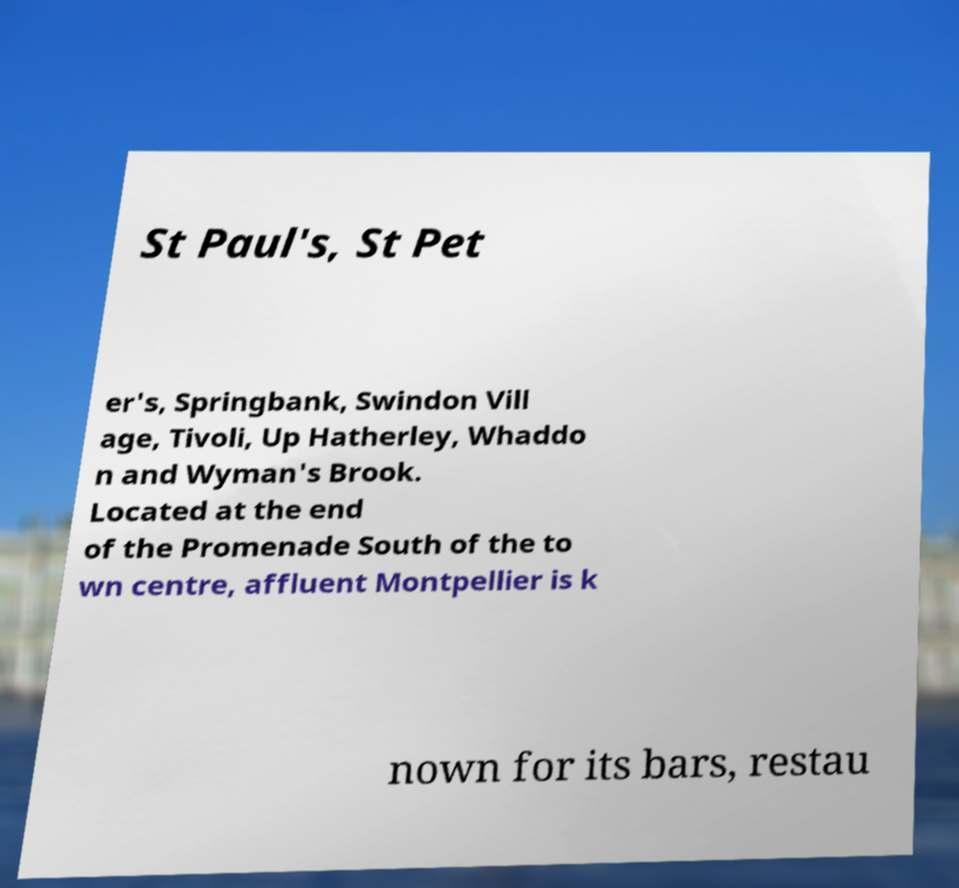Can you read and provide the text displayed in the image?This photo seems to have some interesting text. Can you extract and type it out for me? St Paul's, St Pet er's, Springbank, Swindon Vill age, Tivoli, Up Hatherley, Whaddo n and Wyman's Brook. Located at the end of the Promenade South of the to wn centre, affluent Montpellier is k nown for its bars, restau 